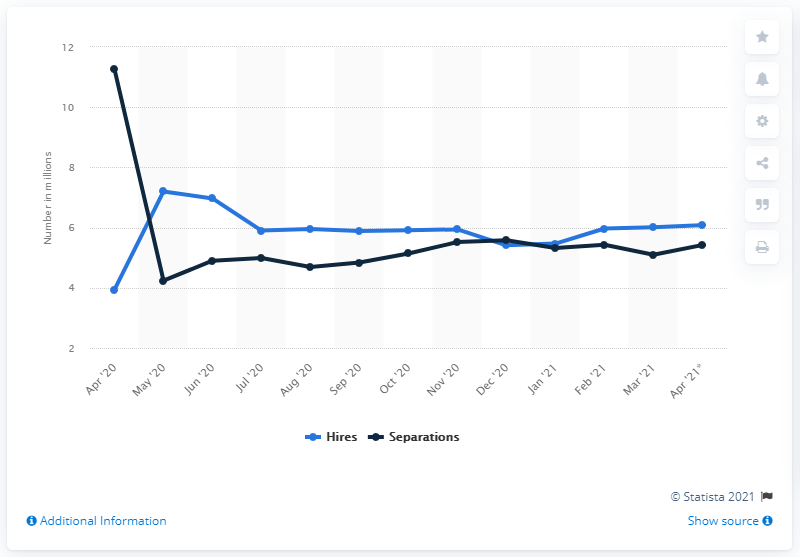List a handful of essential elements in this visual. In April 2021, there were 6.08 nonfarm hires. In April 2021, the seasonally adjusted number of total separations was 5.42. 